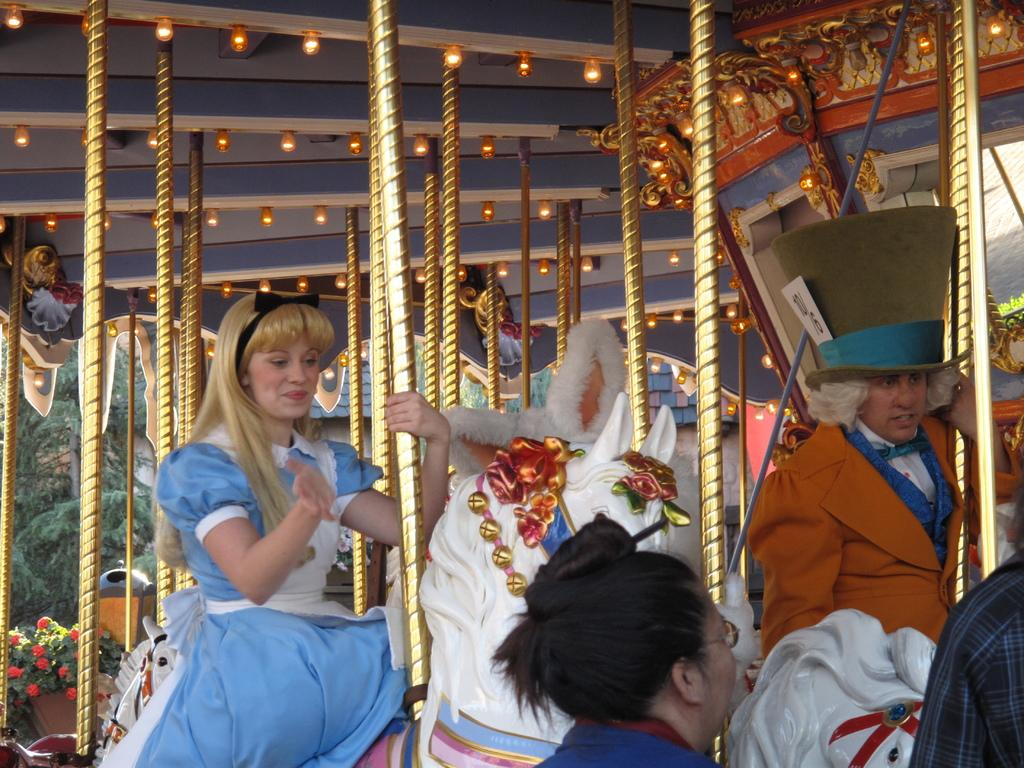What type of attraction is featured in the image? There is an amusement park ride in the picture. Are there any people using the ride? Yes, there are people sitting on the ride. What additional feature can be seen in the image? Lights are visible in the image. What type of vegetation is on the left side of the image? There are plants on the left side of the image. What type of table is used for serving wine in the image? There is no table or wine present in the image; it features an amusement park ride with people sitting on it, lights, and plants. 